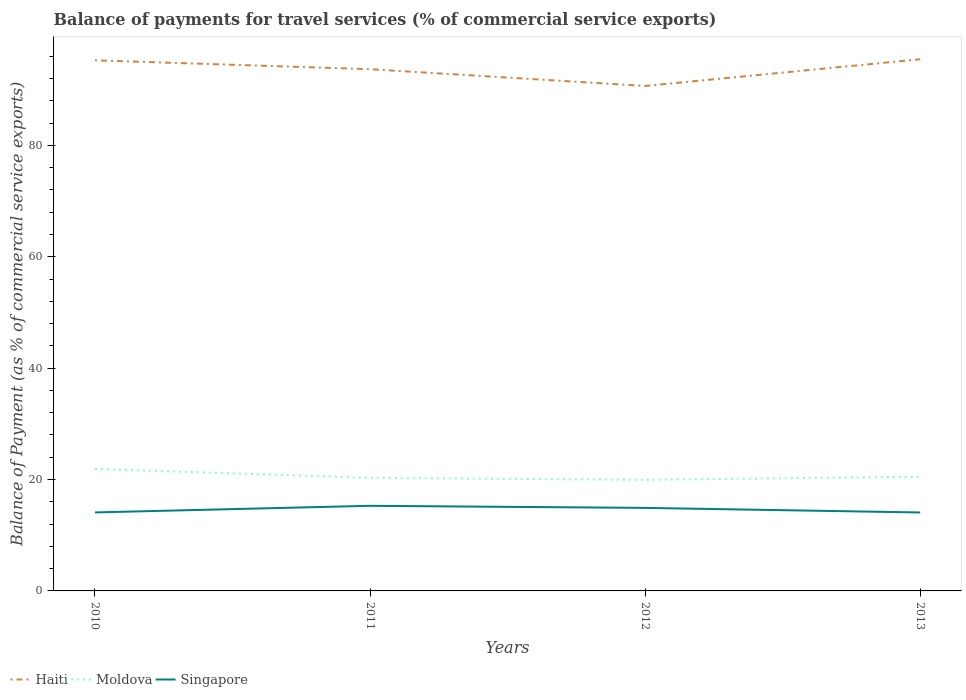How many different coloured lines are there?
Provide a short and direct response. 3. Is the number of lines equal to the number of legend labels?
Ensure brevity in your answer.  Yes. Across all years, what is the maximum balance of payments for travel services in Moldova?
Your answer should be very brief. 19.95. In which year was the balance of payments for travel services in Singapore maximum?
Offer a very short reply. 2013. What is the total balance of payments for travel services in Singapore in the graph?
Offer a terse response. 1.2. What is the difference between the highest and the second highest balance of payments for travel services in Moldova?
Make the answer very short. 1.95. How many years are there in the graph?
Give a very brief answer. 4. Does the graph contain any zero values?
Your answer should be very brief. No. Where does the legend appear in the graph?
Offer a terse response. Bottom left. How are the legend labels stacked?
Offer a terse response. Horizontal. What is the title of the graph?
Provide a succinct answer. Balance of payments for travel services (% of commercial service exports). Does "Middle East & North Africa (developing only)" appear as one of the legend labels in the graph?
Offer a very short reply. No. What is the label or title of the X-axis?
Give a very brief answer. Years. What is the label or title of the Y-axis?
Offer a very short reply. Balance of Payment (as % of commercial service exports). What is the Balance of Payment (as % of commercial service exports) of Haiti in 2010?
Your response must be concise. 95.27. What is the Balance of Payment (as % of commercial service exports) in Moldova in 2010?
Give a very brief answer. 21.9. What is the Balance of Payment (as % of commercial service exports) in Singapore in 2010?
Your response must be concise. 14.1. What is the Balance of Payment (as % of commercial service exports) of Haiti in 2011?
Your answer should be compact. 93.68. What is the Balance of Payment (as % of commercial service exports) of Moldova in 2011?
Give a very brief answer. 20.31. What is the Balance of Payment (as % of commercial service exports) in Singapore in 2011?
Ensure brevity in your answer.  15.29. What is the Balance of Payment (as % of commercial service exports) in Haiti in 2012?
Your answer should be very brief. 90.67. What is the Balance of Payment (as % of commercial service exports) of Moldova in 2012?
Offer a terse response. 19.95. What is the Balance of Payment (as % of commercial service exports) of Singapore in 2012?
Ensure brevity in your answer.  14.91. What is the Balance of Payment (as % of commercial service exports) of Haiti in 2013?
Your answer should be compact. 95.47. What is the Balance of Payment (as % of commercial service exports) of Moldova in 2013?
Offer a very short reply. 20.52. What is the Balance of Payment (as % of commercial service exports) in Singapore in 2013?
Keep it short and to the point. 14.09. Across all years, what is the maximum Balance of Payment (as % of commercial service exports) of Haiti?
Offer a terse response. 95.47. Across all years, what is the maximum Balance of Payment (as % of commercial service exports) of Moldova?
Give a very brief answer. 21.9. Across all years, what is the maximum Balance of Payment (as % of commercial service exports) of Singapore?
Your answer should be compact. 15.29. Across all years, what is the minimum Balance of Payment (as % of commercial service exports) of Haiti?
Provide a succinct answer. 90.67. Across all years, what is the minimum Balance of Payment (as % of commercial service exports) of Moldova?
Offer a terse response. 19.95. Across all years, what is the minimum Balance of Payment (as % of commercial service exports) in Singapore?
Provide a short and direct response. 14.09. What is the total Balance of Payment (as % of commercial service exports) of Haiti in the graph?
Make the answer very short. 375.1. What is the total Balance of Payment (as % of commercial service exports) of Moldova in the graph?
Your answer should be very brief. 82.67. What is the total Balance of Payment (as % of commercial service exports) of Singapore in the graph?
Make the answer very short. 58.38. What is the difference between the Balance of Payment (as % of commercial service exports) in Haiti in 2010 and that in 2011?
Your response must be concise. 1.59. What is the difference between the Balance of Payment (as % of commercial service exports) of Moldova in 2010 and that in 2011?
Offer a terse response. 1.59. What is the difference between the Balance of Payment (as % of commercial service exports) in Singapore in 2010 and that in 2011?
Provide a short and direct response. -1.19. What is the difference between the Balance of Payment (as % of commercial service exports) in Haiti in 2010 and that in 2012?
Provide a short and direct response. 4.6. What is the difference between the Balance of Payment (as % of commercial service exports) of Moldova in 2010 and that in 2012?
Offer a very short reply. 1.95. What is the difference between the Balance of Payment (as % of commercial service exports) in Singapore in 2010 and that in 2012?
Provide a short and direct response. -0.81. What is the difference between the Balance of Payment (as % of commercial service exports) of Haiti in 2010 and that in 2013?
Your answer should be very brief. -0.2. What is the difference between the Balance of Payment (as % of commercial service exports) of Moldova in 2010 and that in 2013?
Offer a terse response. 1.38. What is the difference between the Balance of Payment (as % of commercial service exports) in Singapore in 2010 and that in 2013?
Provide a succinct answer. 0.01. What is the difference between the Balance of Payment (as % of commercial service exports) of Haiti in 2011 and that in 2012?
Your answer should be compact. 3.01. What is the difference between the Balance of Payment (as % of commercial service exports) of Moldova in 2011 and that in 2012?
Offer a terse response. 0.36. What is the difference between the Balance of Payment (as % of commercial service exports) in Singapore in 2011 and that in 2012?
Your response must be concise. 0.38. What is the difference between the Balance of Payment (as % of commercial service exports) of Haiti in 2011 and that in 2013?
Your answer should be very brief. -1.79. What is the difference between the Balance of Payment (as % of commercial service exports) of Moldova in 2011 and that in 2013?
Provide a succinct answer. -0.21. What is the difference between the Balance of Payment (as % of commercial service exports) in Singapore in 2011 and that in 2013?
Your answer should be compact. 1.2. What is the difference between the Balance of Payment (as % of commercial service exports) of Haiti in 2012 and that in 2013?
Offer a terse response. -4.8. What is the difference between the Balance of Payment (as % of commercial service exports) in Moldova in 2012 and that in 2013?
Provide a succinct answer. -0.57. What is the difference between the Balance of Payment (as % of commercial service exports) in Singapore in 2012 and that in 2013?
Your answer should be very brief. 0.82. What is the difference between the Balance of Payment (as % of commercial service exports) of Haiti in 2010 and the Balance of Payment (as % of commercial service exports) of Moldova in 2011?
Keep it short and to the point. 74.97. What is the difference between the Balance of Payment (as % of commercial service exports) in Haiti in 2010 and the Balance of Payment (as % of commercial service exports) in Singapore in 2011?
Offer a terse response. 79.99. What is the difference between the Balance of Payment (as % of commercial service exports) of Moldova in 2010 and the Balance of Payment (as % of commercial service exports) of Singapore in 2011?
Your response must be concise. 6.61. What is the difference between the Balance of Payment (as % of commercial service exports) in Haiti in 2010 and the Balance of Payment (as % of commercial service exports) in Moldova in 2012?
Offer a very short reply. 75.33. What is the difference between the Balance of Payment (as % of commercial service exports) of Haiti in 2010 and the Balance of Payment (as % of commercial service exports) of Singapore in 2012?
Offer a very short reply. 80.36. What is the difference between the Balance of Payment (as % of commercial service exports) of Moldova in 2010 and the Balance of Payment (as % of commercial service exports) of Singapore in 2012?
Offer a terse response. 6.99. What is the difference between the Balance of Payment (as % of commercial service exports) in Haiti in 2010 and the Balance of Payment (as % of commercial service exports) in Moldova in 2013?
Offer a very short reply. 74.76. What is the difference between the Balance of Payment (as % of commercial service exports) in Haiti in 2010 and the Balance of Payment (as % of commercial service exports) in Singapore in 2013?
Ensure brevity in your answer.  81.19. What is the difference between the Balance of Payment (as % of commercial service exports) in Moldova in 2010 and the Balance of Payment (as % of commercial service exports) in Singapore in 2013?
Your answer should be very brief. 7.81. What is the difference between the Balance of Payment (as % of commercial service exports) in Haiti in 2011 and the Balance of Payment (as % of commercial service exports) in Moldova in 2012?
Ensure brevity in your answer.  73.74. What is the difference between the Balance of Payment (as % of commercial service exports) in Haiti in 2011 and the Balance of Payment (as % of commercial service exports) in Singapore in 2012?
Your answer should be compact. 78.77. What is the difference between the Balance of Payment (as % of commercial service exports) of Moldova in 2011 and the Balance of Payment (as % of commercial service exports) of Singapore in 2012?
Give a very brief answer. 5.4. What is the difference between the Balance of Payment (as % of commercial service exports) in Haiti in 2011 and the Balance of Payment (as % of commercial service exports) in Moldova in 2013?
Make the answer very short. 73.16. What is the difference between the Balance of Payment (as % of commercial service exports) in Haiti in 2011 and the Balance of Payment (as % of commercial service exports) in Singapore in 2013?
Make the answer very short. 79.6. What is the difference between the Balance of Payment (as % of commercial service exports) of Moldova in 2011 and the Balance of Payment (as % of commercial service exports) of Singapore in 2013?
Ensure brevity in your answer.  6.22. What is the difference between the Balance of Payment (as % of commercial service exports) of Haiti in 2012 and the Balance of Payment (as % of commercial service exports) of Moldova in 2013?
Your answer should be very brief. 70.16. What is the difference between the Balance of Payment (as % of commercial service exports) in Haiti in 2012 and the Balance of Payment (as % of commercial service exports) in Singapore in 2013?
Keep it short and to the point. 76.59. What is the difference between the Balance of Payment (as % of commercial service exports) in Moldova in 2012 and the Balance of Payment (as % of commercial service exports) in Singapore in 2013?
Offer a very short reply. 5.86. What is the average Balance of Payment (as % of commercial service exports) of Haiti per year?
Your answer should be very brief. 93.78. What is the average Balance of Payment (as % of commercial service exports) in Moldova per year?
Provide a succinct answer. 20.67. What is the average Balance of Payment (as % of commercial service exports) of Singapore per year?
Offer a terse response. 14.6. In the year 2010, what is the difference between the Balance of Payment (as % of commercial service exports) in Haiti and Balance of Payment (as % of commercial service exports) in Moldova?
Give a very brief answer. 73.38. In the year 2010, what is the difference between the Balance of Payment (as % of commercial service exports) in Haiti and Balance of Payment (as % of commercial service exports) in Singapore?
Offer a very short reply. 81.18. In the year 2010, what is the difference between the Balance of Payment (as % of commercial service exports) in Moldova and Balance of Payment (as % of commercial service exports) in Singapore?
Keep it short and to the point. 7.8. In the year 2011, what is the difference between the Balance of Payment (as % of commercial service exports) in Haiti and Balance of Payment (as % of commercial service exports) in Moldova?
Keep it short and to the point. 73.37. In the year 2011, what is the difference between the Balance of Payment (as % of commercial service exports) of Haiti and Balance of Payment (as % of commercial service exports) of Singapore?
Provide a succinct answer. 78.4. In the year 2011, what is the difference between the Balance of Payment (as % of commercial service exports) in Moldova and Balance of Payment (as % of commercial service exports) in Singapore?
Give a very brief answer. 5.02. In the year 2012, what is the difference between the Balance of Payment (as % of commercial service exports) in Haiti and Balance of Payment (as % of commercial service exports) in Moldova?
Your response must be concise. 70.73. In the year 2012, what is the difference between the Balance of Payment (as % of commercial service exports) of Haiti and Balance of Payment (as % of commercial service exports) of Singapore?
Offer a terse response. 75.76. In the year 2012, what is the difference between the Balance of Payment (as % of commercial service exports) in Moldova and Balance of Payment (as % of commercial service exports) in Singapore?
Keep it short and to the point. 5.04. In the year 2013, what is the difference between the Balance of Payment (as % of commercial service exports) of Haiti and Balance of Payment (as % of commercial service exports) of Moldova?
Provide a succinct answer. 74.95. In the year 2013, what is the difference between the Balance of Payment (as % of commercial service exports) in Haiti and Balance of Payment (as % of commercial service exports) in Singapore?
Your response must be concise. 81.38. In the year 2013, what is the difference between the Balance of Payment (as % of commercial service exports) in Moldova and Balance of Payment (as % of commercial service exports) in Singapore?
Your answer should be compact. 6.43. What is the ratio of the Balance of Payment (as % of commercial service exports) in Haiti in 2010 to that in 2011?
Provide a short and direct response. 1.02. What is the ratio of the Balance of Payment (as % of commercial service exports) of Moldova in 2010 to that in 2011?
Provide a succinct answer. 1.08. What is the ratio of the Balance of Payment (as % of commercial service exports) of Singapore in 2010 to that in 2011?
Provide a short and direct response. 0.92. What is the ratio of the Balance of Payment (as % of commercial service exports) in Haiti in 2010 to that in 2012?
Provide a short and direct response. 1.05. What is the ratio of the Balance of Payment (as % of commercial service exports) in Moldova in 2010 to that in 2012?
Provide a succinct answer. 1.1. What is the ratio of the Balance of Payment (as % of commercial service exports) in Singapore in 2010 to that in 2012?
Offer a very short reply. 0.95. What is the ratio of the Balance of Payment (as % of commercial service exports) of Haiti in 2010 to that in 2013?
Your response must be concise. 1. What is the ratio of the Balance of Payment (as % of commercial service exports) of Moldova in 2010 to that in 2013?
Provide a succinct answer. 1.07. What is the ratio of the Balance of Payment (as % of commercial service exports) of Singapore in 2010 to that in 2013?
Give a very brief answer. 1. What is the ratio of the Balance of Payment (as % of commercial service exports) in Haiti in 2011 to that in 2012?
Provide a short and direct response. 1.03. What is the ratio of the Balance of Payment (as % of commercial service exports) of Moldova in 2011 to that in 2012?
Make the answer very short. 1.02. What is the ratio of the Balance of Payment (as % of commercial service exports) in Singapore in 2011 to that in 2012?
Give a very brief answer. 1.03. What is the ratio of the Balance of Payment (as % of commercial service exports) of Haiti in 2011 to that in 2013?
Your response must be concise. 0.98. What is the ratio of the Balance of Payment (as % of commercial service exports) of Singapore in 2011 to that in 2013?
Your answer should be very brief. 1.09. What is the ratio of the Balance of Payment (as % of commercial service exports) of Haiti in 2012 to that in 2013?
Provide a succinct answer. 0.95. What is the ratio of the Balance of Payment (as % of commercial service exports) of Moldova in 2012 to that in 2013?
Ensure brevity in your answer.  0.97. What is the ratio of the Balance of Payment (as % of commercial service exports) in Singapore in 2012 to that in 2013?
Provide a short and direct response. 1.06. What is the difference between the highest and the second highest Balance of Payment (as % of commercial service exports) of Haiti?
Your answer should be very brief. 0.2. What is the difference between the highest and the second highest Balance of Payment (as % of commercial service exports) of Moldova?
Your answer should be compact. 1.38. What is the difference between the highest and the second highest Balance of Payment (as % of commercial service exports) of Singapore?
Provide a short and direct response. 0.38. What is the difference between the highest and the lowest Balance of Payment (as % of commercial service exports) in Haiti?
Ensure brevity in your answer.  4.8. What is the difference between the highest and the lowest Balance of Payment (as % of commercial service exports) in Moldova?
Keep it short and to the point. 1.95. What is the difference between the highest and the lowest Balance of Payment (as % of commercial service exports) of Singapore?
Offer a terse response. 1.2. 